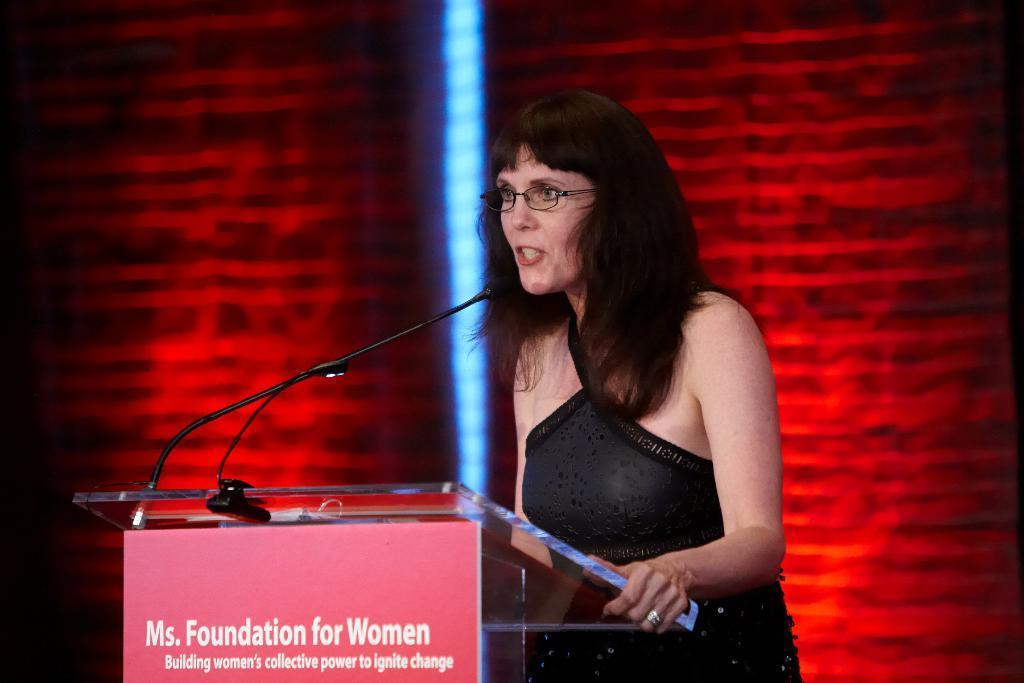Please provide a concise description of this image. In this image, we can see a woman standing and she is wearing specs, she is speaking in the black color microphone, in the background there is a red color wall. 